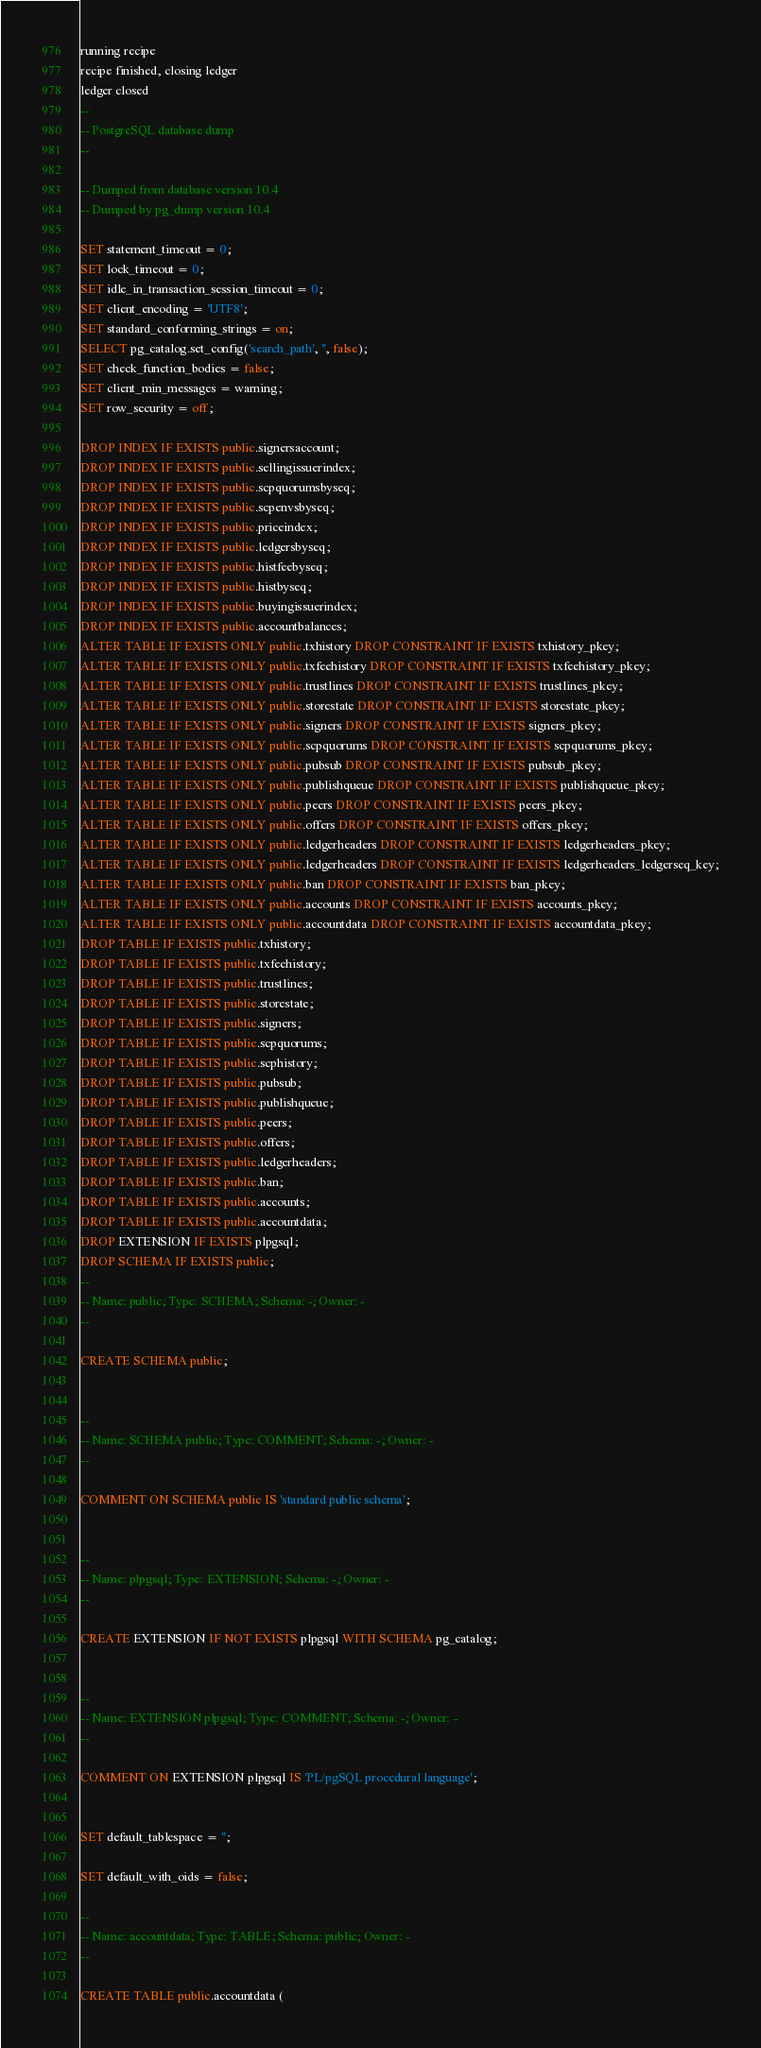<code> <loc_0><loc_0><loc_500><loc_500><_SQL_>running recipe
recipe finished, closing ledger
ledger closed
--
-- PostgreSQL database dump
--

-- Dumped from database version 10.4
-- Dumped by pg_dump version 10.4

SET statement_timeout = 0;
SET lock_timeout = 0;
SET idle_in_transaction_session_timeout = 0;
SET client_encoding = 'UTF8';
SET standard_conforming_strings = on;
SELECT pg_catalog.set_config('search_path', '', false);
SET check_function_bodies = false;
SET client_min_messages = warning;
SET row_security = off;

DROP INDEX IF EXISTS public.signersaccount;
DROP INDEX IF EXISTS public.sellingissuerindex;
DROP INDEX IF EXISTS public.scpquorumsbyseq;
DROP INDEX IF EXISTS public.scpenvsbyseq;
DROP INDEX IF EXISTS public.priceindex;
DROP INDEX IF EXISTS public.ledgersbyseq;
DROP INDEX IF EXISTS public.histfeebyseq;
DROP INDEX IF EXISTS public.histbyseq;
DROP INDEX IF EXISTS public.buyingissuerindex;
DROP INDEX IF EXISTS public.accountbalances;
ALTER TABLE IF EXISTS ONLY public.txhistory DROP CONSTRAINT IF EXISTS txhistory_pkey;
ALTER TABLE IF EXISTS ONLY public.txfeehistory DROP CONSTRAINT IF EXISTS txfeehistory_pkey;
ALTER TABLE IF EXISTS ONLY public.trustlines DROP CONSTRAINT IF EXISTS trustlines_pkey;
ALTER TABLE IF EXISTS ONLY public.storestate DROP CONSTRAINT IF EXISTS storestate_pkey;
ALTER TABLE IF EXISTS ONLY public.signers DROP CONSTRAINT IF EXISTS signers_pkey;
ALTER TABLE IF EXISTS ONLY public.scpquorums DROP CONSTRAINT IF EXISTS scpquorums_pkey;
ALTER TABLE IF EXISTS ONLY public.pubsub DROP CONSTRAINT IF EXISTS pubsub_pkey;
ALTER TABLE IF EXISTS ONLY public.publishqueue DROP CONSTRAINT IF EXISTS publishqueue_pkey;
ALTER TABLE IF EXISTS ONLY public.peers DROP CONSTRAINT IF EXISTS peers_pkey;
ALTER TABLE IF EXISTS ONLY public.offers DROP CONSTRAINT IF EXISTS offers_pkey;
ALTER TABLE IF EXISTS ONLY public.ledgerheaders DROP CONSTRAINT IF EXISTS ledgerheaders_pkey;
ALTER TABLE IF EXISTS ONLY public.ledgerheaders DROP CONSTRAINT IF EXISTS ledgerheaders_ledgerseq_key;
ALTER TABLE IF EXISTS ONLY public.ban DROP CONSTRAINT IF EXISTS ban_pkey;
ALTER TABLE IF EXISTS ONLY public.accounts DROP CONSTRAINT IF EXISTS accounts_pkey;
ALTER TABLE IF EXISTS ONLY public.accountdata DROP CONSTRAINT IF EXISTS accountdata_pkey;
DROP TABLE IF EXISTS public.txhistory;
DROP TABLE IF EXISTS public.txfeehistory;
DROP TABLE IF EXISTS public.trustlines;
DROP TABLE IF EXISTS public.storestate;
DROP TABLE IF EXISTS public.signers;
DROP TABLE IF EXISTS public.scpquorums;
DROP TABLE IF EXISTS public.scphistory;
DROP TABLE IF EXISTS public.pubsub;
DROP TABLE IF EXISTS public.publishqueue;
DROP TABLE IF EXISTS public.peers;
DROP TABLE IF EXISTS public.offers;
DROP TABLE IF EXISTS public.ledgerheaders;
DROP TABLE IF EXISTS public.ban;
DROP TABLE IF EXISTS public.accounts;
DROP TABLE IF EXISTS public.accountdata;
DROP EXTENSION IF EXISTS plpgsql;
DROP SCHEMA IF EXISTS public;
--
-- Name: public; Type: SCHEMA; Schema: -; Owner: -
--

CREATE SCHEMA public;


--
-- Name: SCHEMA public; Type: COMMENT; Schema: -; Owner: -
--

COMMENT ON SCHEMA public IS 'standard public schema';


--
-- Name: plpgsql; Type: EXTENSION; Schema: -; Owner: -
--

CREATE EXTENSION IF NOT EXISTS plpgsql WITH SCHEMA pg_catalog;


--
-- Name: EXTENSION plpgsql; Type: COMMENT; Schema: -; Owner: -
--

COMMENT ON EXTENSION plpgsql IS 'PL/pgSQL procedural language';


SET default_tablespace = '';

SET default_with_oids = false;

--
-- Name: accountdata; Type: TABLE; Schema: public; Owner: -
--

CREATE TABLE public.accountdata (</code> 